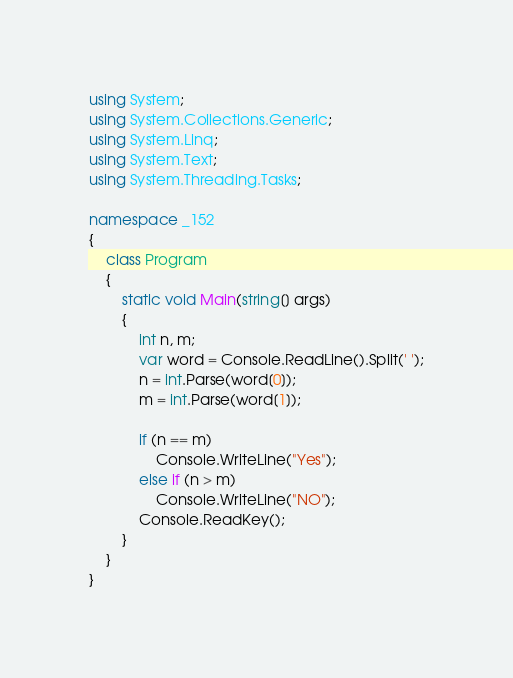Convert code to text. <code><loc_0><loc_0><loc_500><loc_500><_C#_>using System;
using System.Collections.Generic;
using System.Linq;
using System.Text;
using System.Threading.Tasks;

namespace _152
{
	class Program
	{
		static void Main(string[] args)
		{
			int n, m;
			var word = Console.ReadLine().Split(' ');
			n = int.Parse(word[0]);
			m = int.Parse(word[1]);

			if (n == m)
				Console.WriteLine("Yes");
			else if (n > m)
				Console.WriteLine("NO");
			Console.ReadKey();
		}
	}
}
</code> 